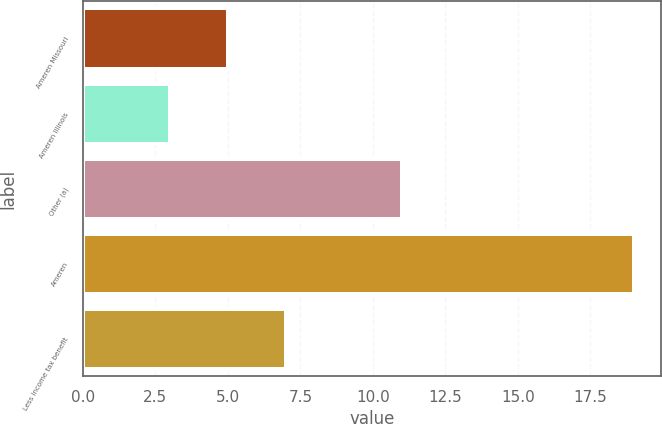<chart> <loc_0><loc_0><loc_500><loc_500><bar_chart><fcel>Ameren Missouri<fcel>Ameren Illinois<fcel>Other (a)<fcel>Ameren<fcel>Less income tax benefit<nl><fcel>5<fcel>3<fcel>11<fcel>19<fcel>7<nl></chart> 